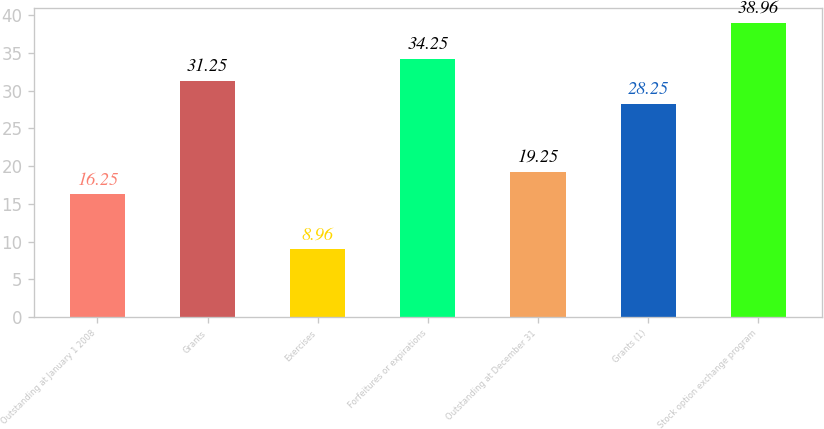<chart> <loc_0><loc_0><loc_500><loc_500><bar_chart><fcel>Outstanding at January 1 2008<fcel>Grants<fcel>Exercises<fcel>Forfeitures or expirations<fcel>Outstanding at December 31<fcel>Grants (1)<fcel>Stock option exchange program<nl><fcel>16.25<fcel>31.25<fcel>8.96<fcel>34.25<fcel>19.25<fcel>28.25<fcel>38.96<nl></chart> 